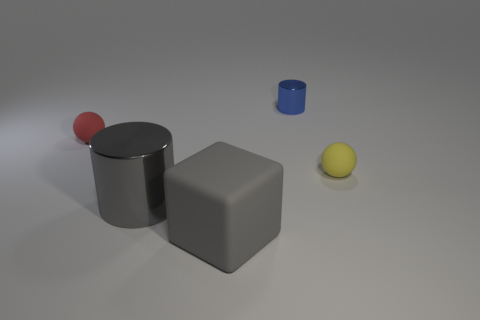There is a metallic thing that is the same color as the large cube; what is its shape?
Your answer should be compact. Cylinder. What is the size of the metal cylinder that is the same color as the rubber cube?
Your answer should be very brief. Large. Are there fewer tiny yellow objects in front of the matte cube than big gray rubber things in front of the large shiny thing?
Keep it short and to the point. Yes. There is a tiny metal thing that is behind the red rubber thing; what shape is it?
Give a very brief answer. Cylinder. Is the yellow sphere made of the same material as the small cylinder?
Ensure brevity in your answer.  No. There is a big thing that is the same shape as the small metallic object; what is it made of?
Give a very brief answer. Metal. Is the number of matte things right of the blue cylinder less than the number of tiny matte spheres?
Make the answer very short. Yes. There is a gray rubber block; how many tiny blue cylinders are behind it?
Your answer should be very brief. 1. Does the tiny matte thing that is on the right side of the blue cylinder have the same shape as the small thing to the left of the blue shiny thing?
Offer a very short reply. Yes. There is a thing that is both to the right of the big metal object and behind the small yellow object; what is its shape?
Offer a terse response. Cylinder. 